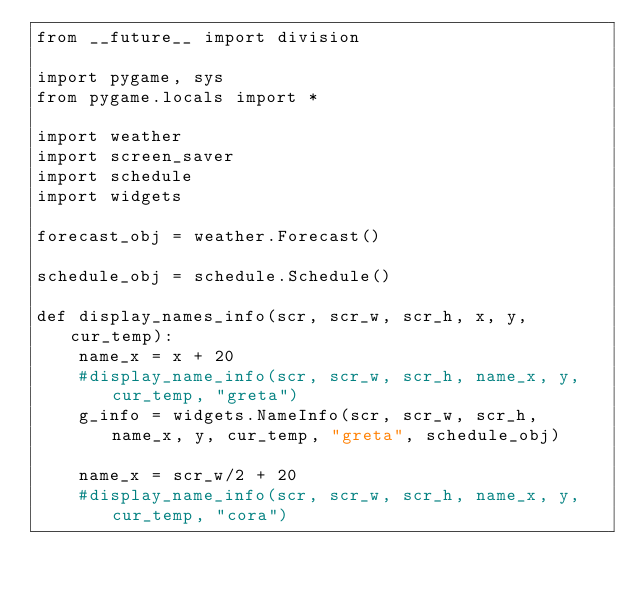<code> <loc_0><loc_0><loc_500><loc_500><_Python_>from __future__ import division

import pygame, sys
from pygame.locals import *

import weather
import screen_saver
import schedule
import widgets

forecast_obj = weather.Forecast()

schedule_obj = schedule.Schedule()

def display_names_info(scr, scr_w, scr_h, x, y, cur_temp):
    name_x = x + 20
    #display_name_info(scr, scr_w, scr_h, name_x, y, cur_temp, "greta")
    g_info = widgets.NameInfo(scr, scr_w, scr_h, name_x, y, cur_temp, "greta", schedule_obj)

    name_x = scr_w/2 + 20
    #display_name_info(scr, scr_w, scr_h, name_x, y, cur_temp, "cora")</code> 